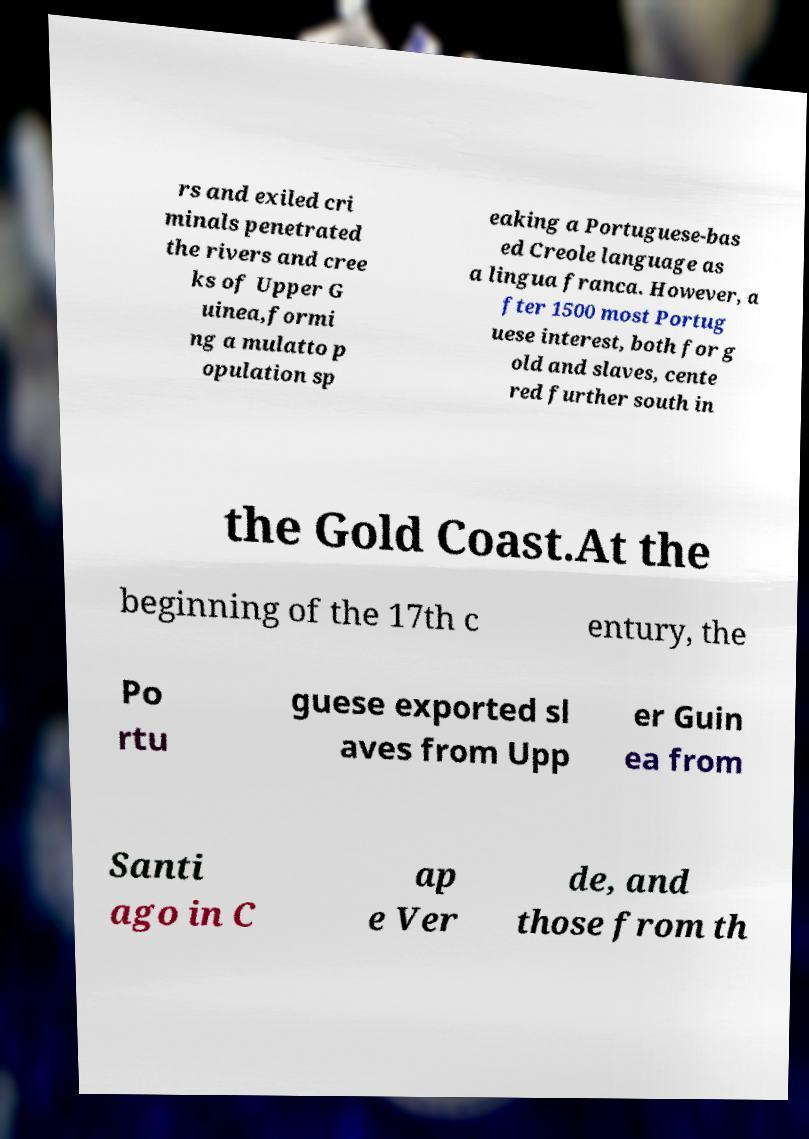Could you extract and type out the text from this image? rs and exiled cri minals penetrated the rivers and cree ks of Upper G uinea,formi ng a mulatto p opulation sp eaking a Portuguese-bas ed Creole language as a lingua franca. However, a fter 1500 most Portug uese interest, both for g old and slaves, cente red further south in the Gold Coast.At the beginning of the 17th c entury, the Po rtu guese exported sl aves from Upp er Guin ea from Santi ago in C ap e Ver de, and those from th 